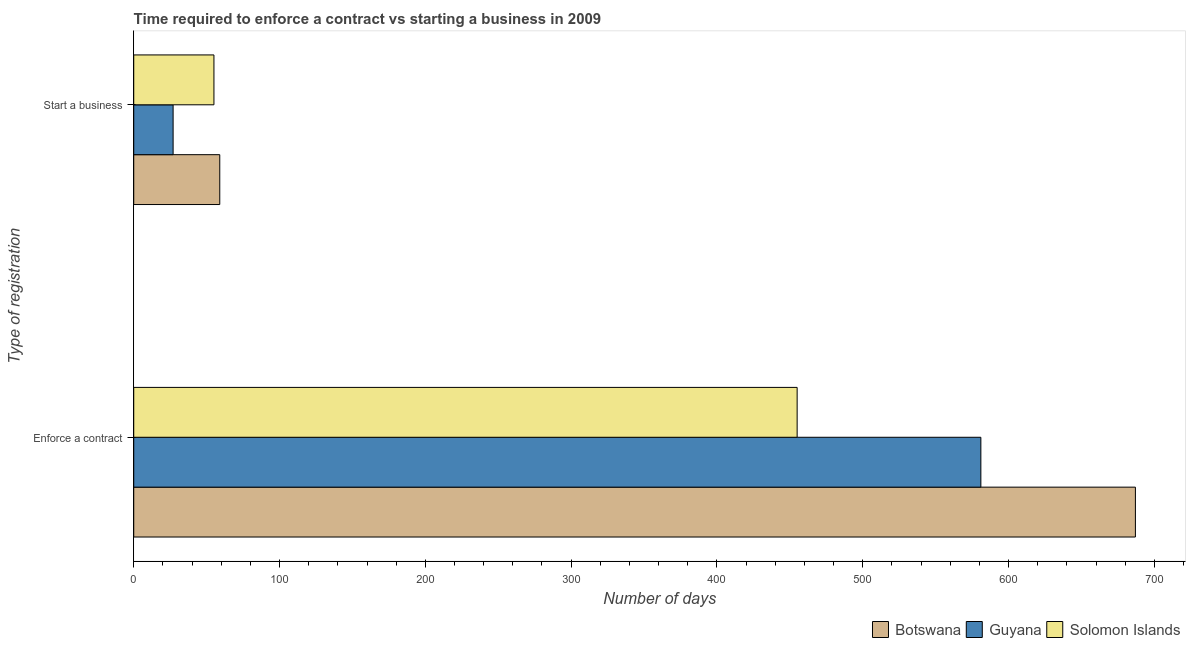How many different coloured bars are there?
Ensure brevity in your answer.  3. Are the number of bars on each tick of the Y-axis equal?
Give a very brief answer. Yes. How many bars are there on the 2nd tick from the top?
Provide a short and direct response. 3. What is the label of the 1st group of bars from the top?
Offer a terse response. Start a business. What is the number of days to start a business in Solomon Islands?
Offer a terse response. 55. Across all countries, what is the maximum number of days to enforece a contract?
Offer a very short reply. 687. Across all countries, what is the minimum number of days to enforece a contract?
Your response must be concise. 455. In which country was the number of days to start a business maximum?
Give a very brief answer. Botswana. In which country was the number of days to enforece a contract minimum?
Keep it short and to the point. Solomon Islands. What is the total number of days to start a business in the graph?
Offer a terse response. 141. What is the difference between the number of days to enforece a contract in Botswana and that in Solomon Islands?
Your answer should be compact. 232. What is the difference between the number of days to start a business in Botswana and the number of days to enforece a contract in Solomon Islands?
Ensure brevity in your answer.  -396. What is the average number of days to enforece a contract per country?
Make the answer very short. 574.33. What is the difference between the number of days to enforece a contract and number of days to start a business in Solomon Islands?
Make the answer very short. 400. What is the ratio of the number of days to enforece a contract in Solomon Islands to that in Botswana?
Provide a succinct answer. 0.66. In how many countries, is the number of days to enforece a contract greater than the average number of days to enforece a contract taken over all countries?
Your response must be concise. 2. What does the 3rd bar from the top in Start a business represents?
Give a very brief answer. Botswana. What does the 1st bar from the bottom in Enforce a contract represents?
Your answer should be very brief. Botswana. Are all the bars in the graph horizontal?
Give a very brief answer. Yes. How many countries are there in the graph?
Offer a very short reply. 3. What is the difference between two consecutive major ticks on the X-axis?
Keep it short and to the point. 100. Are the values on the major ticks of X-axis written in scientific E-notation?
Provide a succinct answer. No. Does the graph contain any zero values?
Offer a very short reply. No. Where does the legend appear in the graph?
Your response must be concise. Bottom right. How many legend labels are there?
Ensure brevity in your answer.  3. How are the legend labels stacked?
Give a very brief answer. Horizontal. What is the title of the graph?
Give a very brief answer. Time required to enforce a contract vs starting a business in 2009. What is the label or title of the X-axis?
Ensure brevity in your answer.  Number of days. What is the label or title of the Y-axis?
Provide a succinct answer. Type of registration. What is the Number of days of Botswana in Enforce a contract?
Offer a very short reply. 687. What is the Number of days of Guyana in Enforce a contract?
Your answer should be compact. 581. What is the Number of days in Solomon Islands in Enforce a contract?
Give a very brief answer. 455. What is the Number of days of Botswana in Start a business?
Ensure brevity in your answer.  59. What is the Number of days in Solomon Islands in Start a business?
Your answer should be very brief. 55. Across all Type of registration, what is the maximum Number of days of Botswana?
Your response must be concise. 687. Across all Type of registration, what is the maximum Number of days in Guyana?
Your answer should be compact. 581. Across all Type of registration, what is the maximum Number of days in Solomon Islands?
Offer a terse response. 455. Across all Type of registration, what is the minimum Number of days in Guyana?
Provide a short and direct response. 27. What is the total Number of days of Botswana in the graph?
Keep it short and to the point. 746. What is the total Number of days in Guyana in the graph?
Your response must be concise. 608. What is the total Number of days in Solomon Islands in the graph?
Offer a terse response. 510. What is the difference between the Number of days in Botswana in Enforce a contract and that in Start a business?
Keep it short and to the point. 628. What is the difference between the Number of days in Guyana in Enforce a contract and that in Start a business?
Keep it short and to the point. 554. What is the difference between the Number of days in Botswana in Enforce a contract and the Number of days in Guyana in Start a business?
Your answer should be compact. 660. What is the difference between the Number of days in Botswana in Enforce a contract and the Number of days in Solomon Islands in Start a business?
Ensure brevity in your answer.  632. What is the difference between the Number of days in Guyana in Enforce a contract and the Number of days in Solomon Islands in Start a business?
Give a very brief answer. 526. What is the average Number of days of Botswana per Type of registration?
Offer a terse response. 373. What is the average Number of days in Guyana per Type of registration?
Ensure brevity in your answer.  304. What is the average Number of days of Solomon Islands per Type of registration?
Ensure brevity in your answer.  255. What is the difference between the Number of days in Botswana and Number of days in Guyana in Enforce a contract?
Offer a terse response. 106. What is the difference between the Number of days in Botswana and Number of days in Solomon Islands in Enforce a contract?
Your answer should be compact. 232. What is the difference between the Number of days in Guyana and Number of days in Solomon Islands in Enforce a contract?
Keep it short and to the point. 126. What is the difference between the Number of days of Botswana and Number of days of Guyana in Start a business?
Ensure brevity in your answer.  32. What is the difference between the Number of days in Botswana and Number of days in Solomon Islands in Start a business?
Your answer should be compact. 4. What is the ratio of the Number of days in Botswana in Enforce a contract to that in Start a business?
Your response must be concise. 11.64. What is the ratio of the Number of days of Guyana in Enforce a contract to that in Start a business?
Offer a terse response. 21.52. What is the ratio of the Number of days of Solomon Islands in Enforce a contract to that in Start a business?
Ensure brevity in your answer.  8.27. What is the difference between the highest and the second highest Number of days of Botswana?
Your answer should be very brief. 628. What is the difference between the highest and the second highest Number of days in Guyana?
Give a very brief answer. 554. What is the difference between the highest and the lowest Number of days in Botswana?
Your answer should be very brief. 628. What is the difference between the highest and the lowest Number of days in Guyana?
Offer a terse response. 554. 